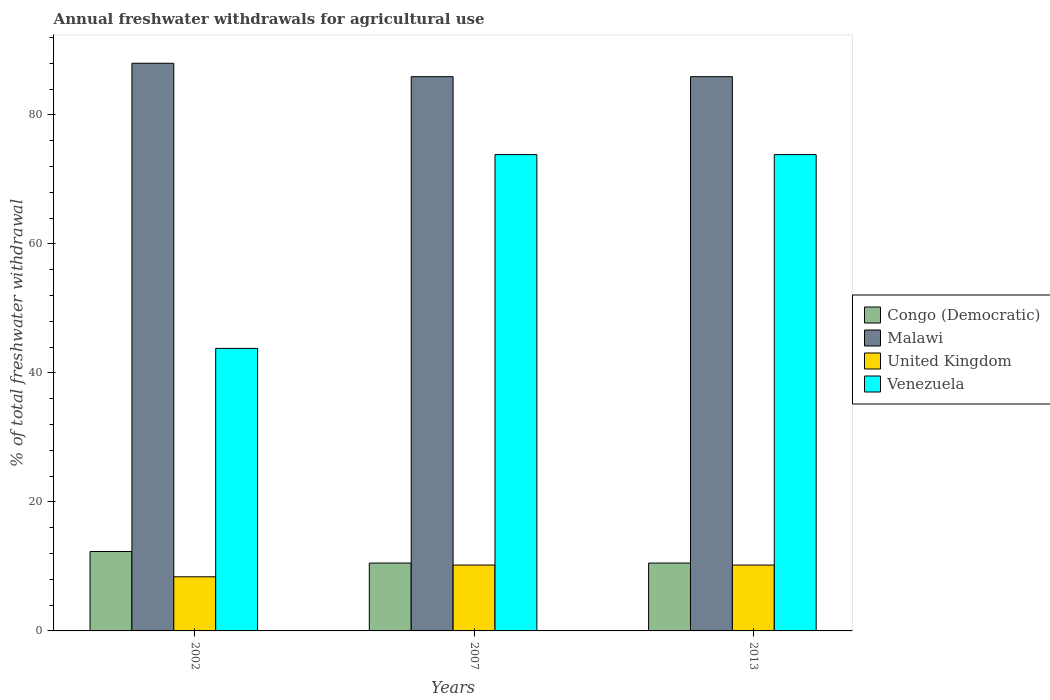How many different coloured bars are there?
Give a very brief answer. 4. How many groups of bars are there?
Your answer should be compact. 3. Are the number of bars on each tick of the X-axis equal?
Provide a succinct answer. Yes. How many bars are there on the 1st tick from the right?
Offer a terse response. 4. In how many cases, is the number of bars for a given year not equal to the number of legend labels?
Provide a short and direct response. 0. What is the total annual withdrawals from freshwater in Congo (Democratic) in 2007?
Your answer should be very brief. 10.52. Across all years, what is the maximum total annual withdrawals from freshwater in Venezuela?
Offer a very short reply. 73.84. Across all years, what is the minimum total annual withdrawals from freshwater in United Kingdom?
Offer a very short reply. 8.39. In which year was the total annual withdrawals from freshwater in Congo (Democratic) maximum?
Make the answer very short. 2002. In which year was the total annual withdrawals from freshwater in Malawi minimum?
Provide a succinct answer. 2007. What is the total total annual withdrawals from freshwater in Congo (Democratic) in the graph?
Provide a short and direct response. 33.35. What is the difference between the total annual withdrawals from freshwater in Venezuela in 2002 and that in 2007?
Keep it short and to the point. -30.04. What is the difference between the total annual withdrawals from freshwater in Venezuela in 2002 and the total annual withdrawals from freshwater in United Kingdom in 2013?
Make the answer very short. 33.59. What is the average total annual withdrawals from freshwater in Malawi per year?
Give a very brief answer. 86.61. In the year 2013, what is the difference between the total annual withdrawals from freshwater in Venezuela and total annual withdrawals from freshwater in Malawi?
Your answer should be very brief. -12.08. In how many years, is the total annual withdrawals from freshwater in Congo (Democratic) greater than 56 %?
Give a very brief answer. 0. What is the ratio of the total annual withdrawals from freshwater in Venezuela in 2007 to that in 2013?
Keep it short and to the point. 1. What is the difference between the highest and the second highest total annual withdrawals from freshwater in Malawi?
Provide a short and direct response. 2.08. What is the difference between the highest and the lowest total annual withdrawals from freshwater in United Kingdom?
Provide a short and direct response. 1.82. In how many years, is the total annual withdrawals from freshwater in Venezuela greater than the average total annual withdrawals from freshwater in Venezuela taken over all years?
Provide a short and direct response. 2. Is it the case that in every year, the sum of the total annual withdrawals from freshwater in United Kingdom and total annual withdrawals from freshwater in Venezuela is greater than the sum of total annual withdrawals from freshwater in Congo (Democratic) and total annual withdrawals from freshwater in Malawi?
Offer a very short reply. No. What does the 2nd bar from the left in 2002 represents?
Give a very brief answer. Malawi. What does the 2nd bar from the right in 2002 represents?
Ensure brevity in your answer.  United Kingdom. How many bars are there?
Your response must be concise. 12. How many years are there in the graph?
Provide a short and direct response. 3. What is the difference between two consecutive major ticks on the Y-axis?
Give a very brief answer. 20. Does the graph contain any zero values?
Give a very brief answer. No. Where does the legend appear in the graph?
Your answer should be very brief. Center right. What is the title of the graph?
Provide a succinct answer. Annual freshwater withdrawals for agricultural use. Does "Czech Republic" appear as one of the legend labels in the graph?
Offer a terse response. No. What is the label or title of the Y-axis?
Keep it short and to the point. % of total freshwater withdrawal. What is the % of total freshwater withdrawal in Congo (Democratic) in 2002?
Offer a terse response. 12.31. What is the % of total freshwater withdrawal in United Kingdom in 2002?
Keep it short and to the point. 8.39. What is the % of total freshwater withdrawal in Venezuela in 2002?
Provide a succinct answer. 43.8. What is the % of total freshwater withdrawal in Congo (Democratic) in 2007?
Your answer should be very brief. 10.52. What is the % of total freshwater withdrawal of Malawi in 2007?
Provide a short and direct response. 85.92. What is the % of total freshwater withdrawal of United Kingdom in 2007?
Provide a succinct answer. 10.21. What is the % of total freshwater withdrawal of Venezuela in 2007?
Make the answer very short. 73.84. What is the % of total freshwater withdrawal in Congo (Democratic) in 2013?
Provide a short and direct response. 10.52. What is the % of total freshwater withdrawal in Malawi in 2013?
Make the answer very short. 85.92. What is the % of total freshwater withdrawal in United Kingdom in 2013?
Offer a very short reply. 10.21. What is the % of total freshwater withdrawal in Venezuela in 2013?
Provide a short and direct response. 73.84. Across all years, what is the maximum % of total freshwater withdrawal of Congo (Democratic)?
Give a very brief answer. 12.31. Across all years, what is the maximum % of total freshwater withdrawal of United Kingdom?
Provide a succinct answer. 10.21. Across all years, what is the maximum % of total freshwater withdrawal in Venezuela?
Offer a terse response. 73.84. Across all years, what is the minimum % of total freshwater withdrawal of Congo (Democratic)?
Keep it short and to the point. 10.52. Across all years, what is the minimum % of total freshwater withdrawal of Malawi?
Your response must be concise. 85.92. Across all years, what is the minimum % of total freshwater withdrawal of United Kingdom?
Your answer should be very brief. 8.39. Across all years, what is the minimum % of total freshwater withdrawal of Venezuela?
Your answer should be very brief. 43.8. What is the total % of total freshwater withdrawal in Congo (Democratic) in the graph?
Your answer should be compact. 33.35. What is the total % of total freshwater withdrawal of Malawi in the graph?
Provide a succinct answer. 259.84. What is the total % of total freshwater withdrawal in United Kingdom in the graph?
Give a very brief answer. 28.81. What is the total % of total freshwater withdrawal in Venezuela in the graph?
Provide a short and direct response. 191.48. What is the difference between the % of total freshwater withdrawal in Congo (Democratic) in 2002 and that in 2007?
Your response must be concise. 1.79. What is the difference between the % of total freshwater withdrawal of Malawi in 2002 and that in 2007?
Your answer should be very brief. 2.08. What is the difference between the % of total freshwater withdrawal in United Kingdom in 2002 and that in 2007?
Ensure brevity in your answer.  -1.82. What is the difference between the % of total freshwater withdrawal in Venezuela in 2002 and that in 2007?
Keep it short and to the point. -30.04. What is the difference between the % of total freshwater withdrawal in Congo (Democratic) in 2002 and that in 2013?
Offer a terse response. 1.79. What is the difference between the % of total freshwater withdrawal of Malawi in 2002 and that in 2013?
Keep it short and to the point. 2.08. What is the difference between the % of total freshwater withdrawal of United Kingdom in 2002 and that in 2013?
Your response must be concise. -1.82. What is the difference between the % of total freshwater withdrawal of Venezuela in 2002 and that in 2013?
Provide a short and direct response. -30.04. What is the difference between the % of total freshwater withdrawal in Congo (Democratic) in 2007 and that in 2013?
Your response must be concise. 0. What is the difference between the % of total freshwater withdrawal of United Kingdom in 2007 and that in 2013?
Keep it short and to the point. 0. What is the difference between the % of total freshwater withdrawal in Venezuela in 2007 and that in 2013?
Keep it short and to the point. 0. What is the difference between the % of total freshwater withdrawal in Congo (Democratic) in 2002 and the % of total freshwater withdrawal in Malawi in 2007?
Your answer should be compact. -73.61. What is the difference between the % of total freshwater withdrawal in Congo (Democratic) in 2002 and the % of total freshwater withdrawal in Venezuela in 2007?
Give a very brief answer. -61.53. What is the difference between the % of total freshwater withdrawal in Malawi in 2002 and the % of total freshwater withdrawal in United Kingdom in 2007?
Ensure brevity in your answer.  77.79. What is the difference between the % of total freshwater withdrawal of Malawi in 2002 and the % of total freshwater withdrawal of Venezuela in 2007?
Provide a succinct answer. 14.16. What is the difference between the % of total freshwater withdrawal of United Kingdom in 2002 and the % of total freshwater withdrawal of Venezuela in 2007?
Provide a succinct answer. -65.45. What is the difference between the % of total freshwater withdrawal of Congo (Democratic) in 2002 and the % of total freshwater withdrawal of Malawi in 2013?
Your response must be concise. -73.61. What is the difference between the % of total freshwater withdrawal of Congo (Democratic) in 2002 and the % of total freshwater withdrawal of United Kingdom in 2013?
Give a very brief answer. 2.1. What is the difference between the % of total freshwater withdrawal of Congo (Democratic) in 2002 and the % of total freshwater withdrawal of Venezuela in 2013?
Offer a very short reply. -61.53. What is the difference between the % of total freshwater withdrawal of Malawi in 2002 and the % of total freshwater withdrawal of United Kingdom in 2013?
Keep it short and to the point. 77.79. What is the difference between the % of total freshwater withdrawal of Malawi in 2002 and the % of total freshwater withdrawal of Venezuela in 2013?
Your response must be concise. 14.16. What is the difference between the % of total freshwater withdrawal of United Kingdom in 2002 and the % of total freshwater withdrawal of Venezuela in 2013?
Your answer should be compact. -65.45. What is the difference between the % of total freshwater withdrawal of Congo (Democratic) in 2007 and the % of total freshwater withdrawal of Malawi in 2013?
Provide a succinct answer. -75.4. What is the difference between the % of total freshwater withdrawal of Congo (Democratic) in 2007 and the % of total freshwater withdrawal of United Kingdom in 2013?
Make the answer very short. 0.31. What is the difference between the % of total freshwater withdrawal of Congo (Democratic) in 2007 and the % of total freshwater withdrawal of Venezuela in 2013?
Your answer should be very brief. -63.32. What is the difference between the % of total freshwater withdrawal in Malawi in 2007 and the % of total freshwater withdrawal in United Kingdom in 2013?
Keep it short and to the point. 75.71. What is the difference between the % of total freshwater withdrawal of Malawi in 2007 and the % of total freshwater withdrawal of Venezuela in 2013?
Offer a very short reply. 12.08. What is the difference between the % of total freshwater withdrawal in United Kingdom in 2007 and the % of total freshwater withdrawal in Venezuela in 2013?
Keep it short and to the point. -63.63. What is the average % of total freshwater withdrawal of Congo (Democratic) per year?
Your answer should be very brief. 11.12. What is the average % of total freshwater withdrawal in Malawi per year?
Offer a terse response. 86.61. What is the average % of total freshwater withdrawal in United Kingdom per year?
Your response must be concise. 9.6. What is the average % of total freshwater withdrawal in Venezuela per year?
Keep it short and to the point. 63.83. In the year 2002, what is the difference between the % of total freshwater withdrawal in Congo (Democratic) and % of total freshwater withdrawal in Malawi?
Offer a terse response. -75.69. In the year 2002, what is the difference between the % of total freshwater withdrawal of Congo (Democratic) and % of total freshwater withdrawal of United Kingdom?
Give a very brief answer. 3.92. In the year 2002, what is the difference between the % of total freshwater withdrawal in Congo (Democratic) and % of total freshwater withdrawal in Venezuela?
Provide a succinct answer. -31.49. In the year 2002, what is the difference between the % of total freshwater withdrawal in Malawi and % of total freshwater withdrawal in United Kingdom?
Keep it short and to the point. 79.61. In the year 2002, what is the difference between the % of total freshwater withdrawal in Malawi and % of total freshwater withdrawal in Venezuela?
Ensure brevity in your answer.  44.2. In the year 2002, what is the difference between the % of total freshwater withdrawal in United Kingdom and % of total freshwater withdrawal in Venezuela?
Offer a terse response. -35.41. In the year 2007, what is the difference between the % of total freshwater withdrawal in Congo (Democratic) and % of total freshwater withdrawal in Malawi?
Give a very brief answer. -75.4. In the year 2007, what is the difference between the % of total freshwater withdrawal in Congo (Democratic) and % of total freshwater withdrawal in United Kingdom?
Keep it short and to the point. 0.31. In the year 2007, what is the difference between the % of total freshwater withdrawal in Congo (Democratic) and % of total freshwater withdrawal in Venezuela?
Provide a succinct answer. -63.32. In the year 2007, what is the difference between the % of total freshwater withdrawal of Malawi and % of total freshwater withdrawal of United Kingdom?
Offer a terse response. 75.71. In the year 2007, what is the difference between the % of total freshwater withdrawal of Malawi and % of total freshwater withdrawal of Venezuela?
Your response must be concise. 12.08. In the year 2007, what is the difference between the % of total freshwater withdrawal in United Kingdom and % of total freshwater withdrawal in Venezuela?
Make the answer very short. -63.63. In the year 2013, what is the difference between the % of total freshwater withdrawal of Congo (Democratic) and % of total freshwater withdrawal of Malawi?
Offer a terse response. -75.4. In the year 2013, what is the difference between the % of total freshwater withdrawal in Congo (Democratic) and % of total freshwater withdrawal in United Kingdom?
Offer a very short reply. 0.31. In the year 2013, what is the difference between the % of total freshwater withdrawal in Congo (Democratic) and % of total freshwater withdrawal in Venezuela?
Your response must be concise. -63.32. In the year 2013, what is the difference between the % of total freshwater withdrawal in Malawi and % of total freshwater withdrawal in United Kingdom?
Offer a very short reply. 75.71. In the year 2013, what is the difference between the % of total freshwater withdrawal of Malawi and % of total freshwater withdrawal of Venezuela?
Keep it short and to the point. 12.08. In the year 2013, what is the difference between the % of total freshwater withdrawal in United Kingdom and % of total freshwater withdrawal in Venezuela?
Keep it short and to the point. -63.63. What is the ratio of the % of total freshwater withdrawal in Congo (Democratic) in 2002 to that in 2007?
Keep it short and to the point. 1.17. What is the ratio of the % of total freshwater withdrawal in Malawi in 2002 to that in 2007?
Ensure brevity in your answer.  1.02. What is the ratio of the % of total freshwater withdrawal in United Kingdom in 2002 to that in 2007?
Provide a succinct answer. 0.82. What is the ratio of the % of total freshwater withdrawal in Venezuela in 2002 to that in 2007?
Offer a terse response. 0.59. What is the ratio of the % of total freshwater withdrawal in Congo (Democratic) in 2002 to that in 2013?
Offer a terse response. 1.17. What is the ratio of the % of total freshwater withdrawal of Malawi in 2002 to that in 2013?
Offer a very short reply. 1.02. What is the ratio of the % of total freshwater withdrawal in United Kingdom in 2002 to that in 2013?
Your response must be concise. 0.82. What is the ratio of the % of total freshwater withdrawal in Venezuela in 2002 to that in 2013?
Give a very brief answer. 0.59. What is the ratio of the % of total freshwater withdrawal of Congo (Democratic) in 2007 to that in 2013?
Keep it short and to the point. 1. What is the ratio of the % of total freshwater withdrawal of Malawi in 2007 to that in 2013?
Provide a succinct answer. 1. What is the ratio of the % of total freshwater withdrawal in Venezuela in 2007 to that in 2013?
Give a very brief answer. 1. What is the difference between the highest and the second highest % of total freshwater withdrawal of Congo (Democratic)?
Offer a very short reply. 1.79. What is the difference between the highest and the second highest % of total freshwater withdrawal of Malawi?
Provide a short and direct response. 2.08. What is the difference between the highest and the second highest % of total freshwater withdrawal of United Kingdom?
Ensure brevity in your answer.  0. What is the difference between the highest and the lowest % of total freshwater withdrawal in Congo (Democratic)?
Your answer should be very brief. 1.79. What is the difference between the highest and the lowest % of total freshwater withdrawal of Malawi?
Ensure brevity in your answer.  2.08. What is the difference between the highest and the lowest % of total freshwater withdrawal of United Kingdom?
Your response must be concise. 1.82. What is the difference between the highest and the lowest % of total freshwater withdrawal in Venezuela?
Your response must be concise. 30.04. 